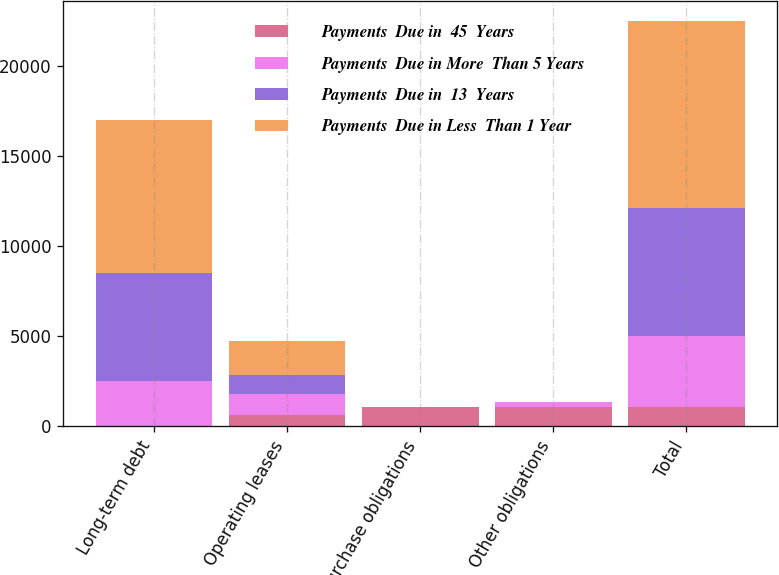<chart> <loc_0><loc_0><loc_500><loc_500><stacked_bar_chart><ecel><fcel>Long-term debt<fcel>Operating leases<fcel>Purchase obligations<fcel>Other obligations<fcel>Total<nl><fcel>Payments  Due in  45  Years<fcel>0<fcel>610<fcel>1068.5<fcel>1081<fcel>1068.5<nl><fcel>Payments  Due in More  Than 5 Years<fcel>2500<fcel>1200<fcel>0<fcel>248<fcel>3948<nl><fcel>Payments  Due in  13  Years<fcel>6000<fcel>1056<fcel>0<fcel>16<fcel>7072<nl><fcel>Payments  Due in Less  Than 1 Year<fcel>8500<fcel>1855<fcel>0<fcel>3<fcel>10358<nl></chart> 